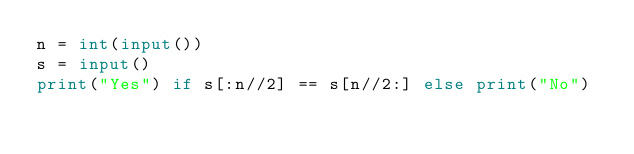<code> <loc_0><loc_0><loc_500><loc_500><_Python_>n = int(input())
s = input()
print("Yes") if s[:n//2] == s[n//2:] else print("No")
</code> 